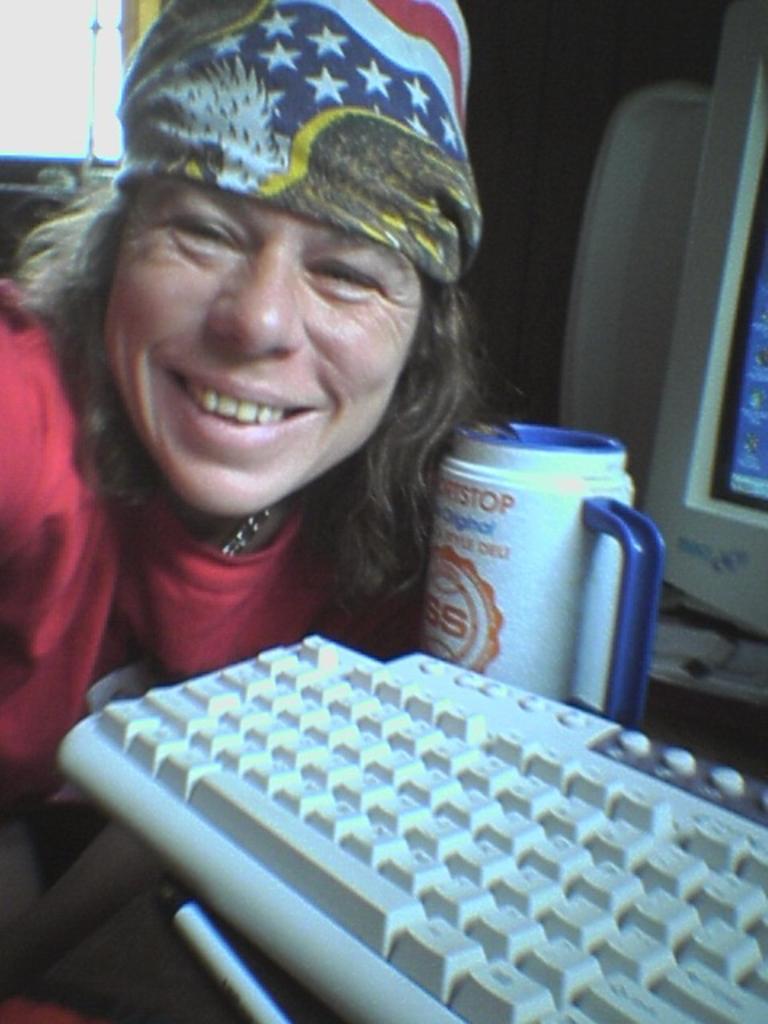Can you describe this image briefly? In the center of the image there is a lady. There is a keyboard. There is a mug. 